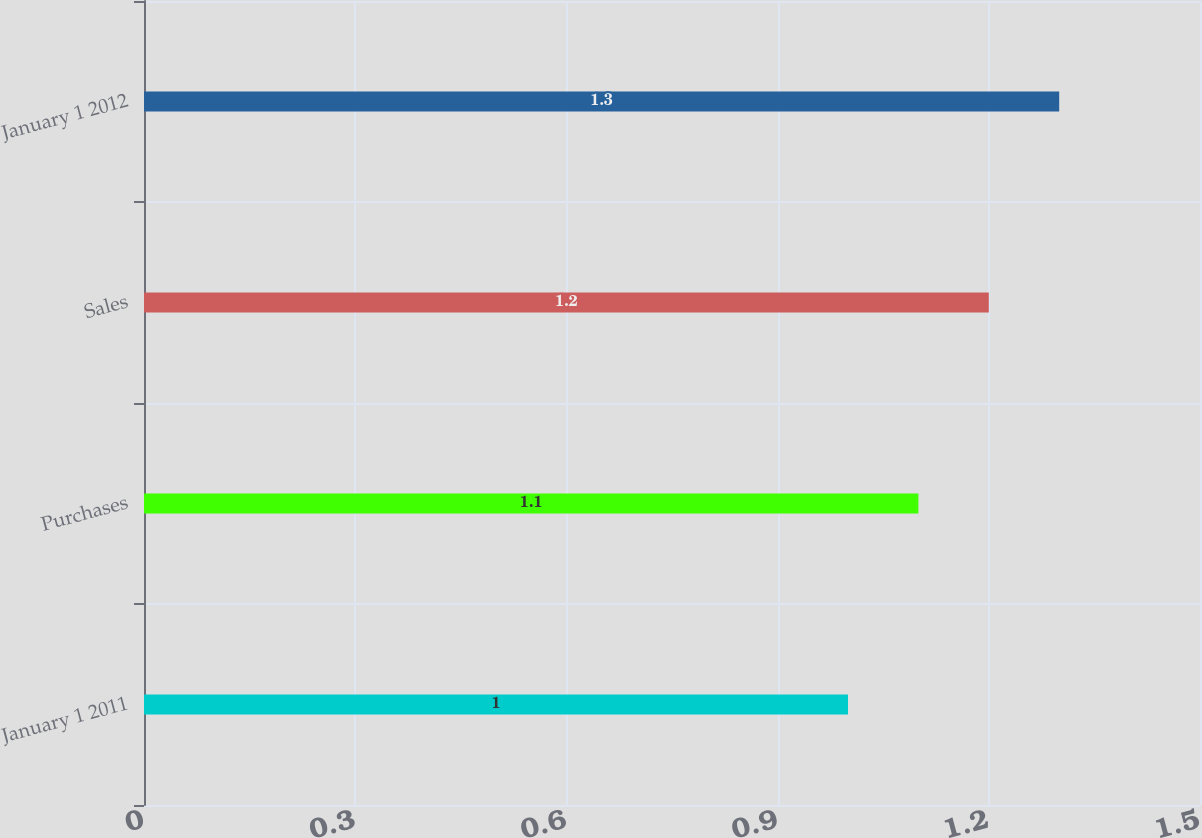Convert chart to OTSL. <chart><loc_0><loc_0><loc_500><loc_500><bar_chart><fcel>January 1 2011<fcel>Purchases<fcel>Sales<fcel>January 1 2012<nl><fcel>1<fcel>1.1<fcel>1.2<fcel>1.3<nl></chart> 